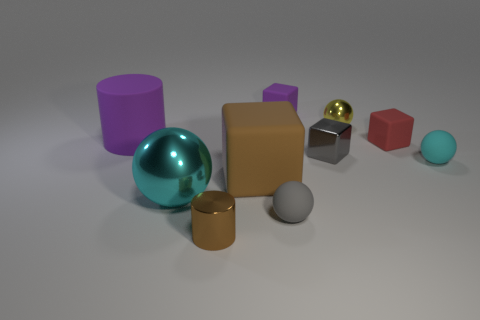Is the number of tiny cyan matte objects less than the number of small blue blocks?
Provide a short and direct response. No. Is there anything else that has the same size as the brown cube?
Your response must be concise. Yes. What is the material of the brown thing that is the same shape as the small red rubber object?
Provide a short and direct response. Rubber. Is the number of cyan objects greater than the number of big metal things?
Give a very brief answer. Yes. How many other objects are there of the same color as the big matte cube?
Your response must be concise. 1. Does the small purple block have the same material as the cyan sphere to the right of the red matte block?
Make the answer very short. Yes. What number of big purple cylinders are on the right side of the small matte block to the right of the purple object behind the tiny yellow shiny object?
Your answer should be very brief. 0. Is the number of small cubes in front of the tiny gray metallic cube less than the number of cubes in front of the small yellow metal ball?
Give a very brief answer. Yes. What number of other objects are there of the same material as the gray block?
Keep it short and to the point. 3. What material is the brown thing that is the same size as the red rubber cube?
Make the answer very short. Metal. 